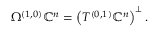<formula> <loc_0><loc_0><loc_500><loc_500>\Omega ^ { ( 1 , 0 ) } \mathbb { C } ^ { n } = \left ( T ^ { ( 0 , 1 ) } \mathbb { C } ^ { n } \right ) ^ { \bot } .</formula> 